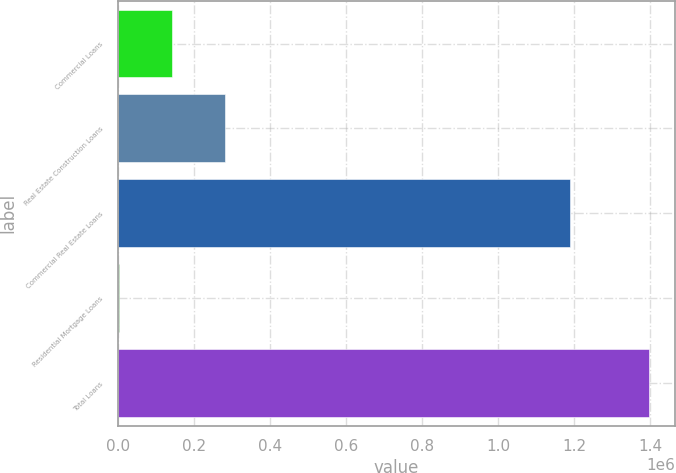<chart> <loc_0><loc_0><loc_500><loc_500><bar_chart><fcel>Commercial Loans<fcel>Real Estate Construction Loans<fcel>Commercial Real Estate Loans<fcel>Residential Mortgage Loans<fcel>Total Loans<nl><fcel>143802<fcel>283003<fcel>1.18966e+06<fcel>4601<fcel>1.39661e+06<nl></chart> 